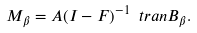<formula> <loc_0><loc_0><loc_500><loc_500>M _ { \beta } = A ( I - F ) ^ { - 1 } \ t r a n { B _ { \beta } } .</formula> 